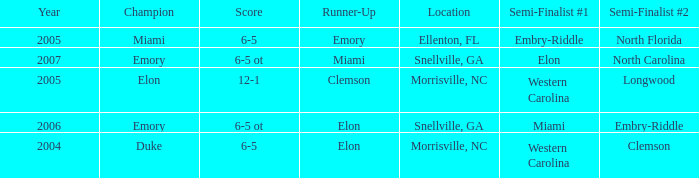When Embry-Riddle made it to the first semi finalist slot, list all the runners up. Emory. 